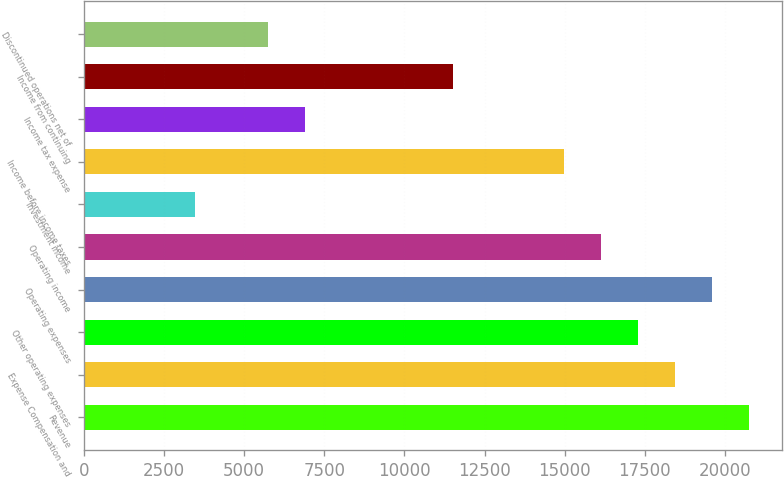Convert chart. <chart><loc_0><loc_0><loc_500><loc_500><bar_chart><fcel>Revenue<fcel>Expense Compensation and<fcel>Other operating expenses<fcel>Operating expenses<fcel>Operating income<fcel>Investment income<fcel>Income before income taxes<fcel>Income tax expense<fcel>Income from continuing<fcel>Discontinued operations net of<nl><fcel>20745.5<fcel>18440.6<fcel>17288.2<fcel>19593<fcel>16135.8<fcel>3459.02<fcel>14983.3<fcel>6916.31<fcel>11526<fcel>5763.88<nl></chart> 